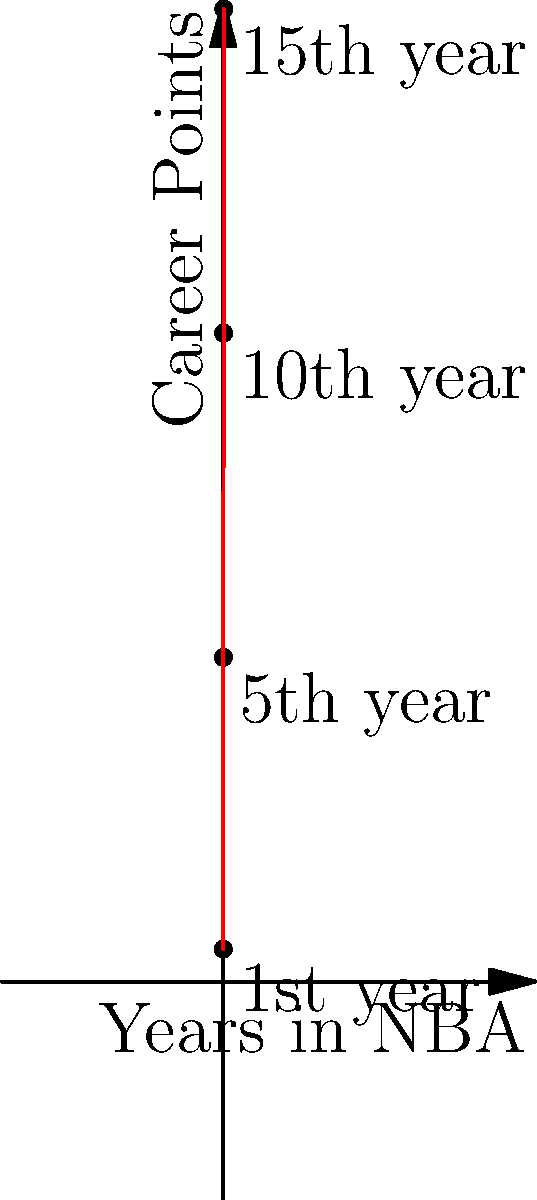In this stylish coordinate plane, we've plotted Michael Jordan's career points against his years in the NBA. If we were to extend this trend line to predict His Airness's career points at the 20-year mark, approximately how many points would he have scored? Let's break this down step-by-step, just like how MJ breaks down his opponents:

1. First, we need to identify the pattern in the given data:
   - 1st year: 1,000 points
   - 5th year: 10,000 points
   - 10th year: 20,000 points
   - 15th year: 30,000 points

2. We can see that every 5 years, Jordan's career points increase by 10,000.

3. To find the 20-year mark, we need to extend this pattern for 5 more years from the 15-year point.

4. Since the increase is 10,000 points every 5 years, we can expect another 10,000 point increase from year 15 to year 20.

5. At year 15, Jordan had 30,000 points. So at year 20, we would expect:
   
   $30,000 + 10,000 = 40,000$ points

Therefore, if we extend the trend line to the 20-year mark, we would predict that Michael Jordan would have scored approximately 40,000 career points.
Answer: 40,000 points 